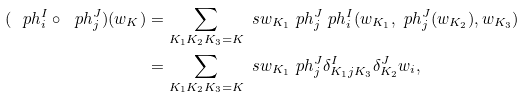Convert formula to latex. <formula><loc_0><loc_0><loc_500><loc_500>( \ p h ^ { I } _ { i } \circ \ p h ^ { J } _ { j } ) ( w _ { K } ) & = \sum _ { K _ { 1 } K _ { 2 } K _ { 3 } = K } \ s { w _ { K _ { 1 } } \ p h ^ { J } _ { j } } \ p h ^ { I } _ { i } ( w _ { K _ { 1 } } , \ p h ^ { J } _ { j } ( w _ { K _ { 2 } } ) , w _ { K _ { 3 } } ) \\ & = \sum _ { K _ { 1 } K _ { 2 } K _ { 3 } = K } \ s { w _ { K _ { 1 } } \ p h ^ { J } _ { j } } \delta ^ { I } _ { K _ { 1 } j K _ { 3 } } \delta ^ { J } _ { K _ { 2 } } w _ { i } ,</formula> 